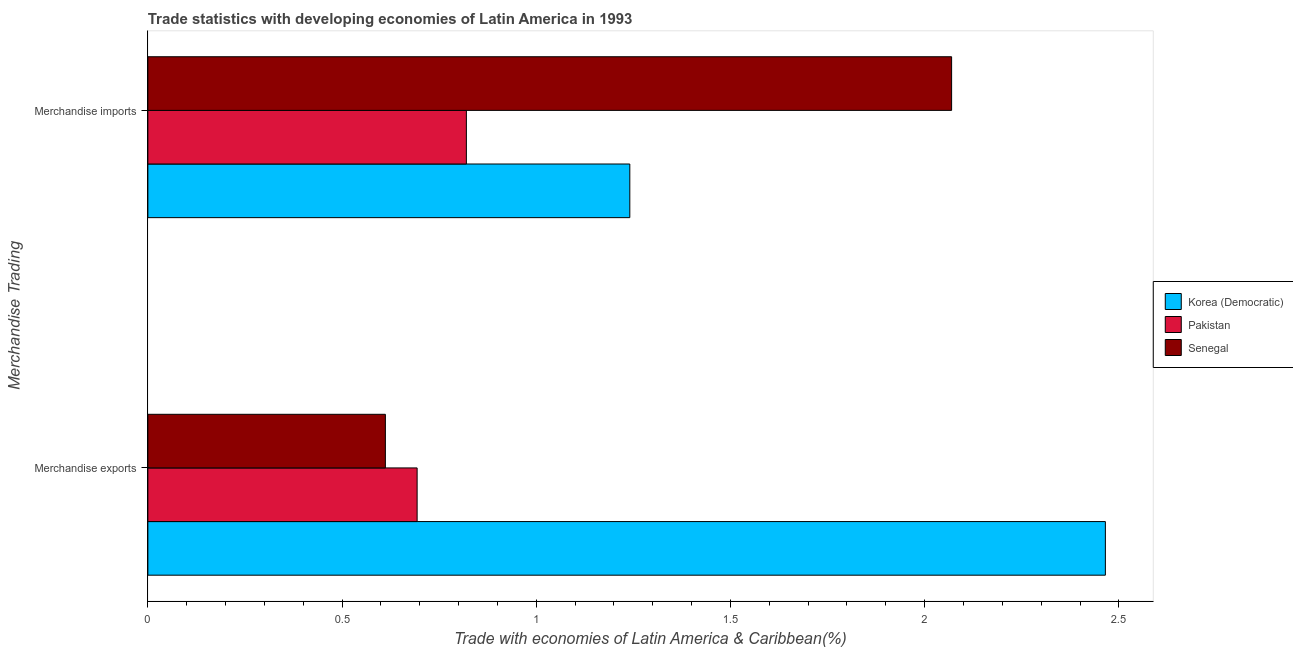How many groups of bars are there?
Give a very brief answer. 2. Are the number of bars per tick equal to the number of legend labels?
Provide a succinct answer. Yes. How many bars are there on the 2nd tick from the bottom?
Provide a short and direct response. 3. What is the label of the 1st group of bars from the top?
Offer a very short reply. Merchandise imports. What is the merchandise imports in Senegal?
Keep it short and to the point. 2.07. Across all countries, what is the maximum merchandise imports?
Your answer should be very brief. 2.07. Across all countries, what is the minimum merchandise imports?
Make the answer very short. 0.82. In which country was the merchandise exports maximum?
Your answer should be very brief. Korea (Democratic). In which country was the merchandise exports minimum?
Your response must be concise. Senegal. What is the total merchandise exports in the graph?
Give a very brief answer. 3.77. What is the difference between the merchandise imports in Korea (Democratic) and that in Senegal?
Offer a terse response. -0.83. What is the difference between the merchandise imports in Korea (Democratic) and the merchandise exports in Senegal?
Make the answer very short. 0.63. What is the average merchandise exports per country?
Make the answer very short. 1.26. What is the difference between the merchandise imports and merchandise exports in Pakistan?
Your response must be concise. 0.13. What is the ratio of the merchandise imports in Korea (Democratic) to that in Senegal?
Offer a terse response. 0.6. What does the 3rd bar from the top in Merchandise exports represents?
Your answer should be very brief. Korea (Democratic). What does the 3rd bar from the bottom in Merchandise exports represents?
Give a very brief answer. Senegal. How many bars are there?
Offer a very short reply. 6. Are all the bars in the graph horizontal?
Your response must be concise. Yes. How many countries are there in the graph?
Provide a short and direct response. 3. What is the difference between two consecutive major ticks on the X-axis?
Make the answer very short. 0.5. Are the values on the major ticks of X-axis written in scientific E-notation?
Offer a very short reply. No. Does the graph contain any zero values?
Give a very brief answer. No. How many legend labels are there?
Your answer should be compact. 3. How are the legend labels stacked?
Make the answer very short. Vertical. What is the title of the graph?
Your answer should be very brief. Trade statistics with developing economies of Latin America in 1993. Does "Poland" appear as one of the legend labels in the graph?
Offer a terse response. No. What is the label or title of the X-axis?
Your response must be concise. Trade with economies of Latin America & Caribbean(%). What is the label or title of the Y-axis?
Make the answer very short. Merchandise Trading. What is the Trade with economies of Latin America & Caribbean(%) in Korea (Democratic) in Merchandise exports?
Offer a very short reply. 2.47. What is the Trade with economies of Latin America & Caribbean(%) of Pakistan in Merchandise exports?
Provide a short and direct response. 0.69. What is the Trade with economies of Latin America & Caribbean(%) in Senegal in Merchandise exports?
Offer a terse response. 0.61. What is the Trade with economies of Latin America & Caribbean(%) in Korea (Democratic) in Merchandise imports?
Provide a succinct answer. 1.24. What is the Trade with economies of Latin America & Caribbean(%) of Pakistan in Merchandise imports?
Give a very brief answer. 0.82. What is the Trade with economies of Latin America & Caribbean(%) of Senegal in Merchandise imports?
Your answer should be very brief. 2.07. Across all Merchandise Trading, what is the maximum Trade with economies of Latin America & Caribbean(%) in Korea (Democratic)?
Keep it short and to the point. 2.47. Across all Merchandise Trading, what is the maximum Trade with economies of Latin America & Caribbean(%) in Pakistan?
Keep it short and to the point. 0.82. Across all Merchandise Trading, what is the maximum Trade with economies of Latin America & Caribbean(%) of Senegal?
Keep it short and to the point. 2.07. Across all Merchandise Trading, what is the minimum Trade with economies of Latin America & Caribbean(%) of Korea (Democratic)?
Provide a short and direct response. 1.24. Across all Merchandise Trading, what is the minimum Trade with economies of Latin America & Caribbean(%) in Pakistan?
Give a very brief answer. 0.69. Across all Merchandise Trading, what is the minimum Trade with economies of Latin America & Caribbean(%) of Senegal?
Make the answer very short. 0.61. What is the total Trade with economies of Latin America & Caribbean(%) in Korea (Democratic) in the graph?
Keep it short and to the point. 3.71. What is the total Trade with economies of Latin America & Caribbean(%) in Pakistan in the graph?
Keep it short and to the point. 1.51. What is the total Trade with economies of Latin America & Caribbean(%) of Senegal in the graph?
Offer a terse response. 2.68. What is the difference between the Trade with economies of Latin America & Caribbean(%) in Korea (Democratic) in Merchandise exports and that in Merchandise imports?
Offer a very short reply. 1.22. What is the difference between the Trade with economies of Latin America & Caribbean(%) of Pakistan in Merchandise exports and that in Merchandise imports?
Your answer should be very brief. -0.13. What is the difference between the Trade with economies of Latin America & Caribbean(%) in Senegal in Merchandise exports and that in Merchandise imports?
Make the answer very short. -1.46. What is the difference between the Trade with economies of Latin America & Caribbean(%) in Korea (Democratic) in Merchandise exports and the Trade with economies of Latin America & Caribbean(%) in Pakistan in Merchandise imports?
Make the answer very short. 1.65. What is the difference between the Trade with economies of Latin America & Caribbean(%) of Korea (Democratic) in Merchandise exports and the Trade with economies of Latin America & Caribbean(%) of Senegal in Merchandise imports?
Offer a terse response. 0.4. What is the difference between the Trade with economies of Latin America & Caribbean(%) in Pakistan in Merchandise exports and the Trade with economies of Latin America & Caribbean(%) in Senegal in Merchandise imports?
Your response must be concise. -1.38. What is the average Trade with economies of Latin America & Caribbean(%) of Korea (Democratic) per Merchandise Trading?
Your response must be concise. 1.85. What is the average Trade with economies of Latin America & Caribbean(%) of Pakistan per Merchandise Trading?
Your answer should be compact. 0.76. What is the average Trade with economies of Latin America & Caribbean(%) in Senegal per Merchandise Trading?
Provide a succinct answer. 1.34. What is the difference between the Trade with economies of Latin America & Caribbean(%) in Korea (Democratic) and Trade with economies of Latin America & Caribbean(%) in Pakistan in Merchandise exports?
Provide a succinct answer. 1.77. What is the difference between the Trade with economies of Latin America & Caribbean(%) of Korea (Democratic) and Trade with economies of Latin America & Caribbean(%) of Senegal in Merchandise exports?
Offer a terse response. 1.85. What is the difference between the Trade with economies of Latin America & Caribbean(%) of Pakistan and Trade with economies of Latin America & Caribbean(%) of Senegal in Merchandise exports?
Offer a very short reply. 0.08. What is the difference between the Trade with economies of Latin America & Caribbean(%) of Korea (Democratic) and Trade with economies of Latin America & Caribbean(%) of Pakistan in Merchandise imports?
Make the answer very short. 0.42. What is the difference between the Trade with economies of Latin America & Caribbean(%) of Korea (Democratic) and Trade with economies of Latin America & Caribbean(%) of Senegal in Merchandise imports?
Provide a short and direct response. -0.83. What is the difference between the Trade with economies of Latin America & Caribbean(%) in Pakistan and Trade with economies of Latin America & Caribbean(%) in Senegal in Merchandise imports?
Give a very brief answer. -1.25. What is the ratio of the Trade with economies of Latin America & Caribbean(%) of Korea (Democratic) in Merchandise exports to that in Merchandise imports?
Your answer should be compact. 1.99. What is the ratio of the Trade with economies of Latin America & Caribbean(%) in Pakistan in Merchandise exports to that in Merchandise imports?
Your answer should be very brief. 0.85. What is the ratio of the Trade with economies of Latin America & Caribbean(%) of Senegal in Merchandise exports to that in Merchandise imports?
Provide a short and direct response. 0.3. What is the difference between the highest and the second highest Trade with economies of Latin America & Caribbean(%) in Korea (Democratic)?
Give a very brief answer. 1.22. What is the difference between the highest and the second highest Trade with economies of Latin America & Caribbean(%) in Pakistan?
Provide a short and direct response. 0.13. What is the difference between the highest and the second highest Trade with economies of Latin America & Caribbean(%) in Senegal?
Offer a very short reply. 1.46. What is the difference between the highest and the lowest Trade with economies of Latin America & Caribbean(%) in Korea (Democratic)?
Offer a terse response. 1.22. What is the difference between the highest and the lowest Trade with economies of Latin America & Caribbean(%) of Pakistan?
Offer a terse response. 0.13. What is the difference between the highest and the lowest Trade with economies of Latin America & Caribbean(%) of Senegal?
Offer a terse response. 1.46. 